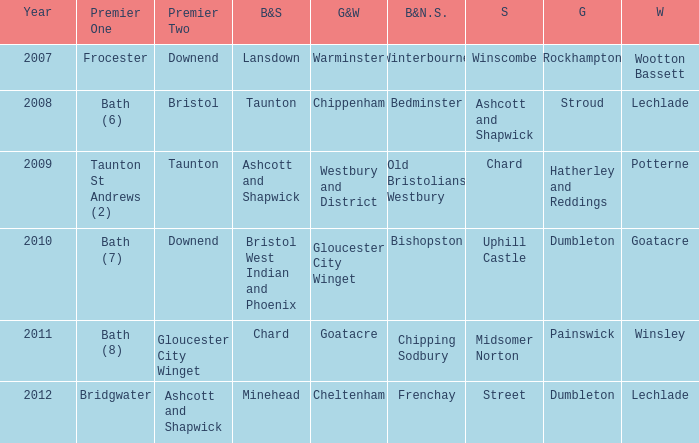What is the year where glos & wilts is gloucester city winget? 2010.0. 